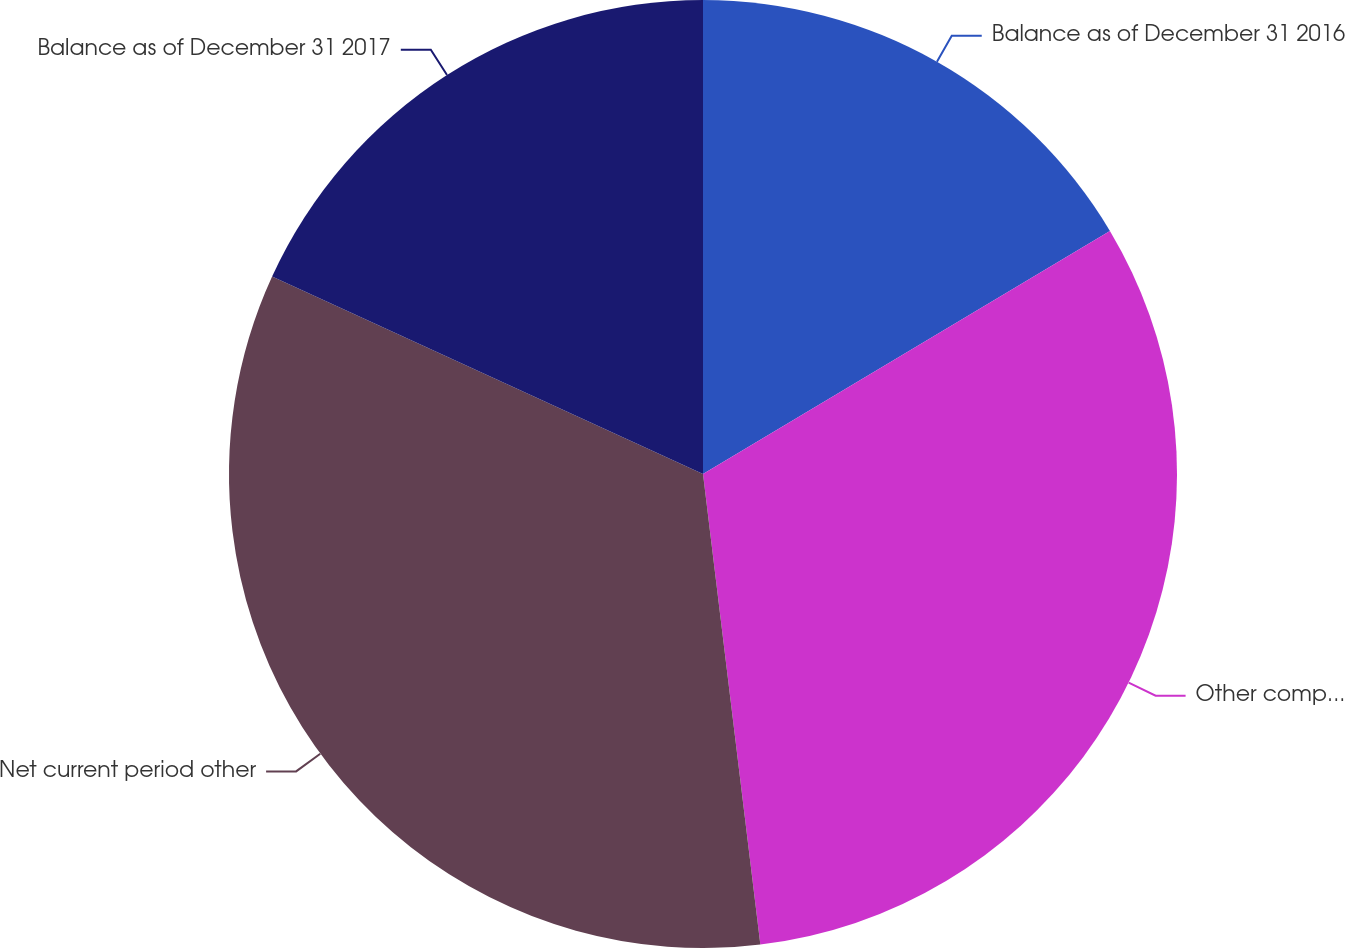<chart> <loc_0><loc_0><loc_500><loc_500><pie_chart><fcel>Balance as of December 31 2016<fcel>Other comprehensive income<fcel>Net current period other<fcel>Balance as of December 31 2017<nl><fcel>16.43%<fcel>31.64%<fcel>33.77%<fcel>18.16%<nl></chart> 